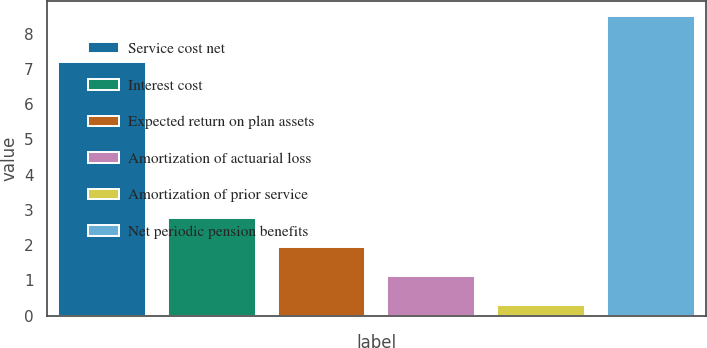Convert chart. <chart><loc_0><loc_0><loc_500><loc_500><bar_chart><fcel>Service cost net<fcel>Interest cost<fcel>Expected return on plan assets<fcel>Amortization of actuarial loss<fcel>Amortization of prior service<fcel>Net periodic pension benefits<nl><fcel>7.2<fcel>2.76<fcel>1.94<fcel>1.12<fcel>0.3<fcel>8.5<nl></chart> 